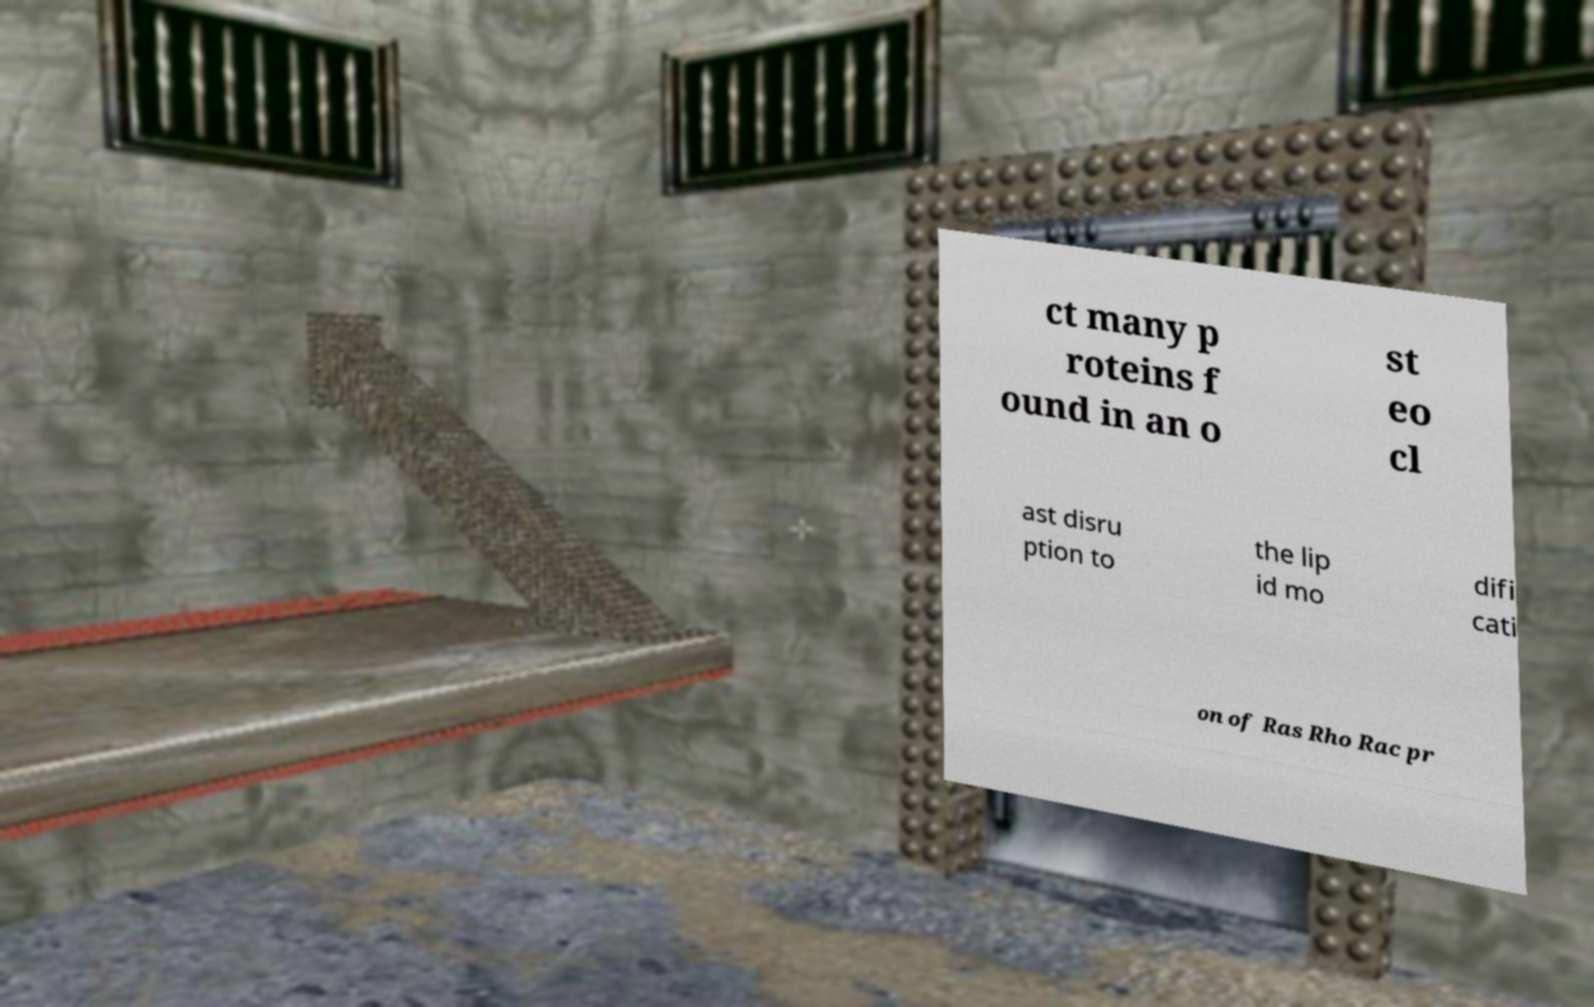Please read and relay the text visible in this image. What does it say? ct many p roteins f ound in an o st eo cl ast disru ption to the lip id mo difi cati on of Ras Rho Rac pr 